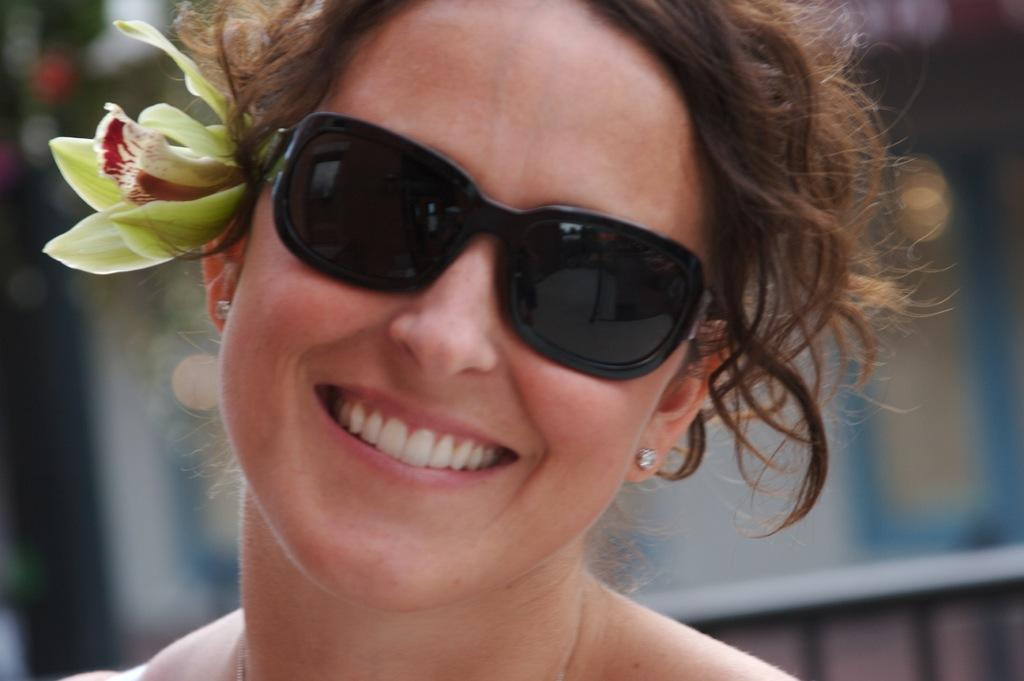Who is present in the image? There is a woman in the image. What is the woman doing in the image? The woman is laughing in the image. What is the woman wearing on her eyes? The woman is wearing goggles on her eyes. What type of accessory is on the woman's ear? There is a flower on the woman's ear. How many cards are visible on the woman's hand in the image? There are no cards visible on the woman's hand in the image. Is there a cobweb in the background of the image? There is no mention of a cobweb in the provided facts, so we cannot determine if one is present in the image. 